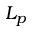Convert formula to latex. <formula><loc_0><loc_0><loc_500><loc_500>L _ { p }</formula> 